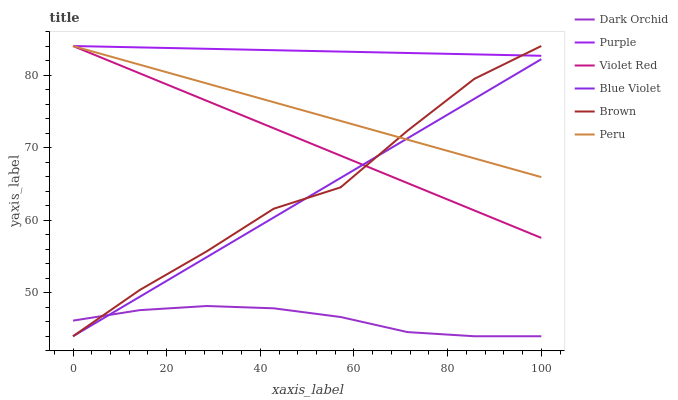Does Violet Red have the minimum area under the curve?
Answer yes or no. No. Does Violet Red have the maximum area under the curve?
Answer yes or no. No. Is Violet Red the smoothest?
Answer yes or no. No. Is Violet Red the roughest?
Answer yes or no. No. Does Violet Red have the lowest value?
Answer yes or no. No. Does Dark Orchid have the highest value?
Answer yes or no. No. Is Dark Orchid less than Purple?
Answer yes or no. Yes. Is Violet Red greater than Dark Orchid?
Answer yes or no. Yes. Does Dark Orchid intersect Purple?
Answer yes or no. No. 